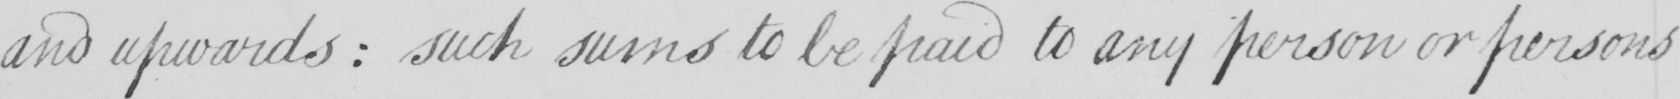What text is written in this handwritten line? and upwards :  such sums to be paid to any person or persons 